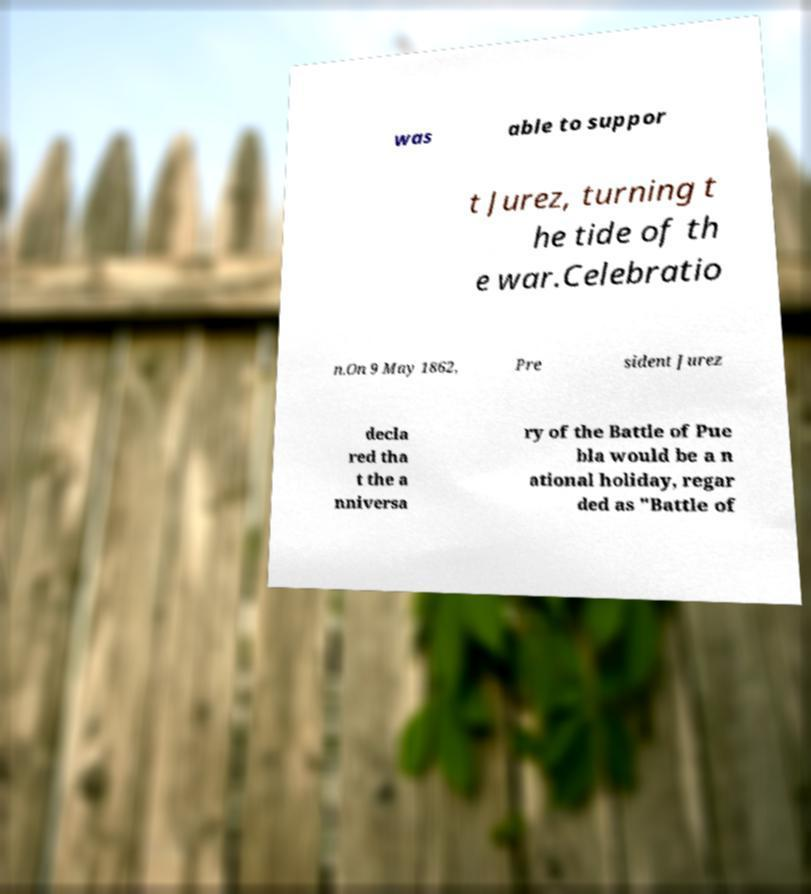What messages or text are displayed in this image? I need them in a readable, typed format. was able to suppor t Jurez, turning t he tide of th e war.Celebratio n.On 9 May 1862, Pre sident Jurez decla red tha t the a nniversa ry of the Battle of Pue bla would be a n ational holiday, regar ded as "Battle of 